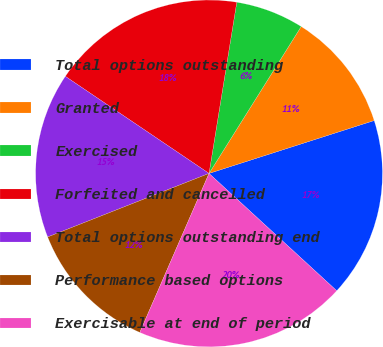Convert chart. <chart><loc_0><loc_0><loc_500><loc_500><pie_chart><fcel>Total options outstanding<fcel>Granted<fcel>Exercised<fcel>Forfeited and cancelled<fcel>Total options outstanding end<fcel>Performance based options<fcel>Exercisable at end of period<nl><fcel>16.76%<fcel>11.15%<fcel>6.36%<fcel>18.1%<fcel>15.43%<fcel>12.49%<fcel>19.71%<nl></chart> 